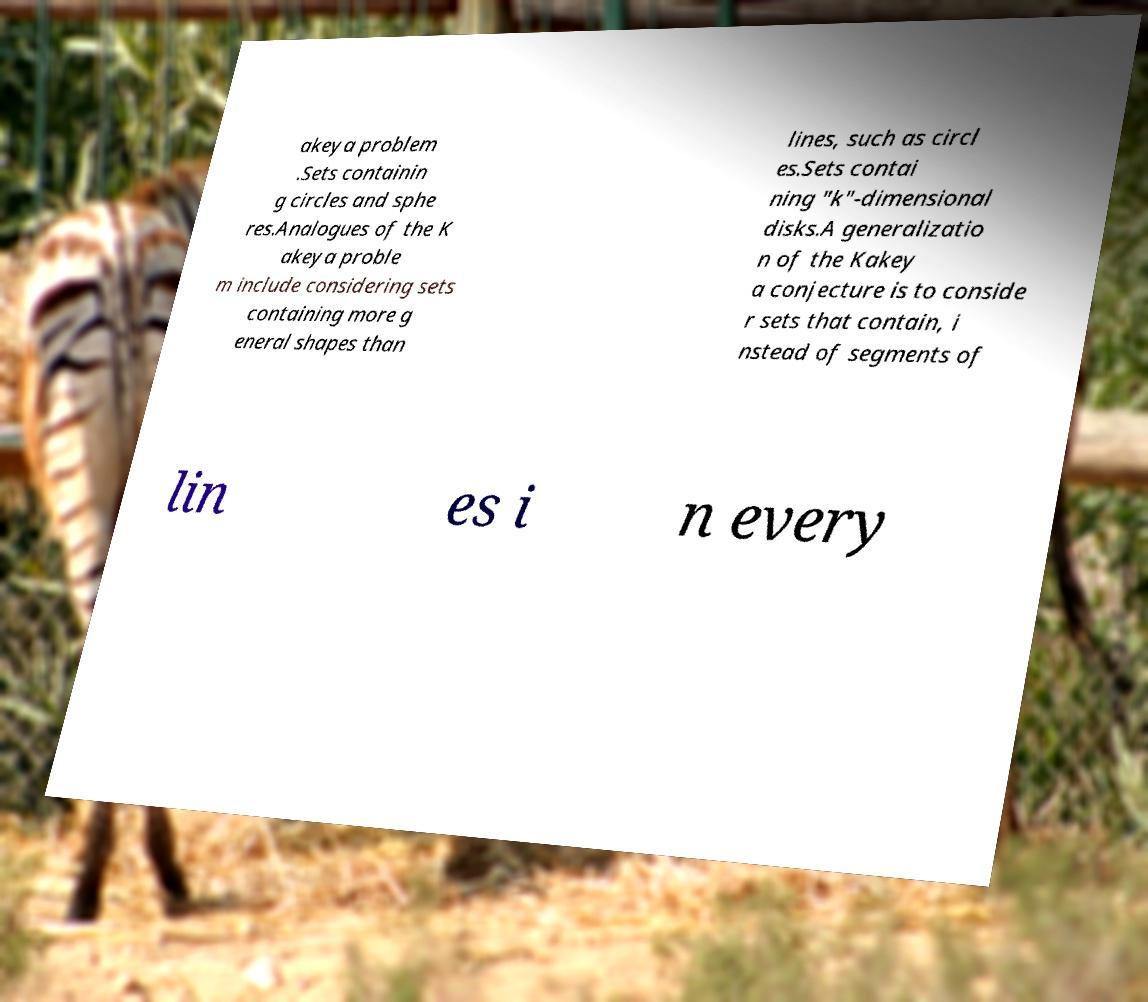Please read and relay the text visible in this image. What does it say? akeya problem .Sets containin g circles and sphe res.Analogues of the K akeya proble m include considering sets containing more g eneral shapes than lines, such as circl es.Sets contai ning "k"-dimensional disks.A generalizatio n of the Kakey a conjecture is to conside r sets that contain, i nstead of segments of lin es i n every 